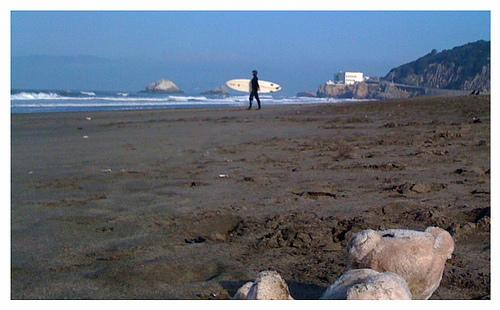Question: what is the man holding?
Choices:
A. His baby.
B. The kite string.
C. His girlfriend's hand.
D. Surfboard.
Answer with the letter. Answer: D Question: where was the photo taken?
Choices:
A. The sand.
B. The lake.
C. School.
D. The bar.
Answer with the letter. Answer: A Question: what is in the sand in the front?
Choices:
A. A bear.
B. A bottle with a message in it.
C. A magic lamp.
D. A severed head.
Answer with the letter. Answer: A 